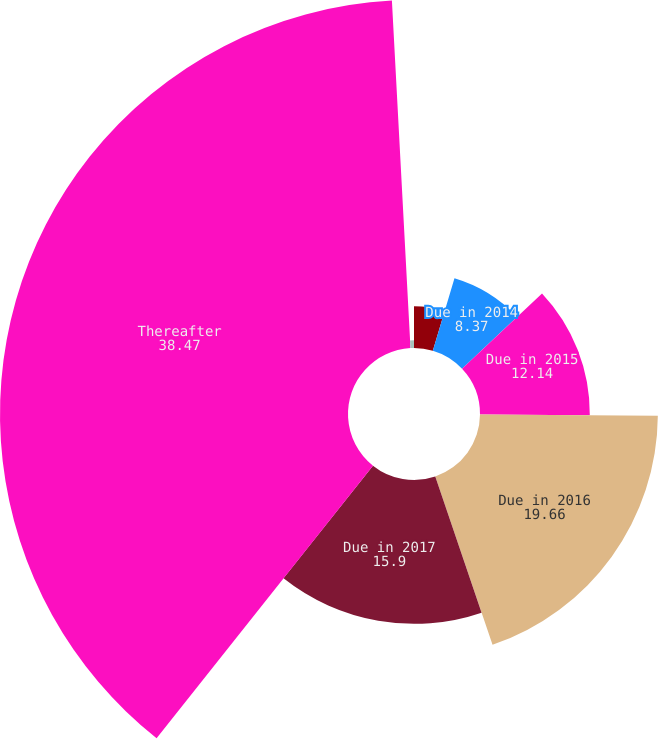<chart> <loc_0><loc_0><loc_500><loc_500><pie_chart><fcel>Due in 2013<fcel>Due in 2014<fcel>Due in 2015<fcel>Due in 2016<fcel>Due in 2017<fcel>Thereafter<fcel>Weighted average coupon at<nl><fcel>4.61%<fcel>8.37%<fcel>12.14%<fcel>19.66%<fcel>15.9%<fcel>38.47%<fcel>0.85%<nl></chart> 